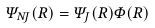<formula> <loc_0><loc_0><loc_500><loc_500>\Psi _ { N J } ( R ) = \Psi _ { J } ( R ) \Phi ( R )</formula> 